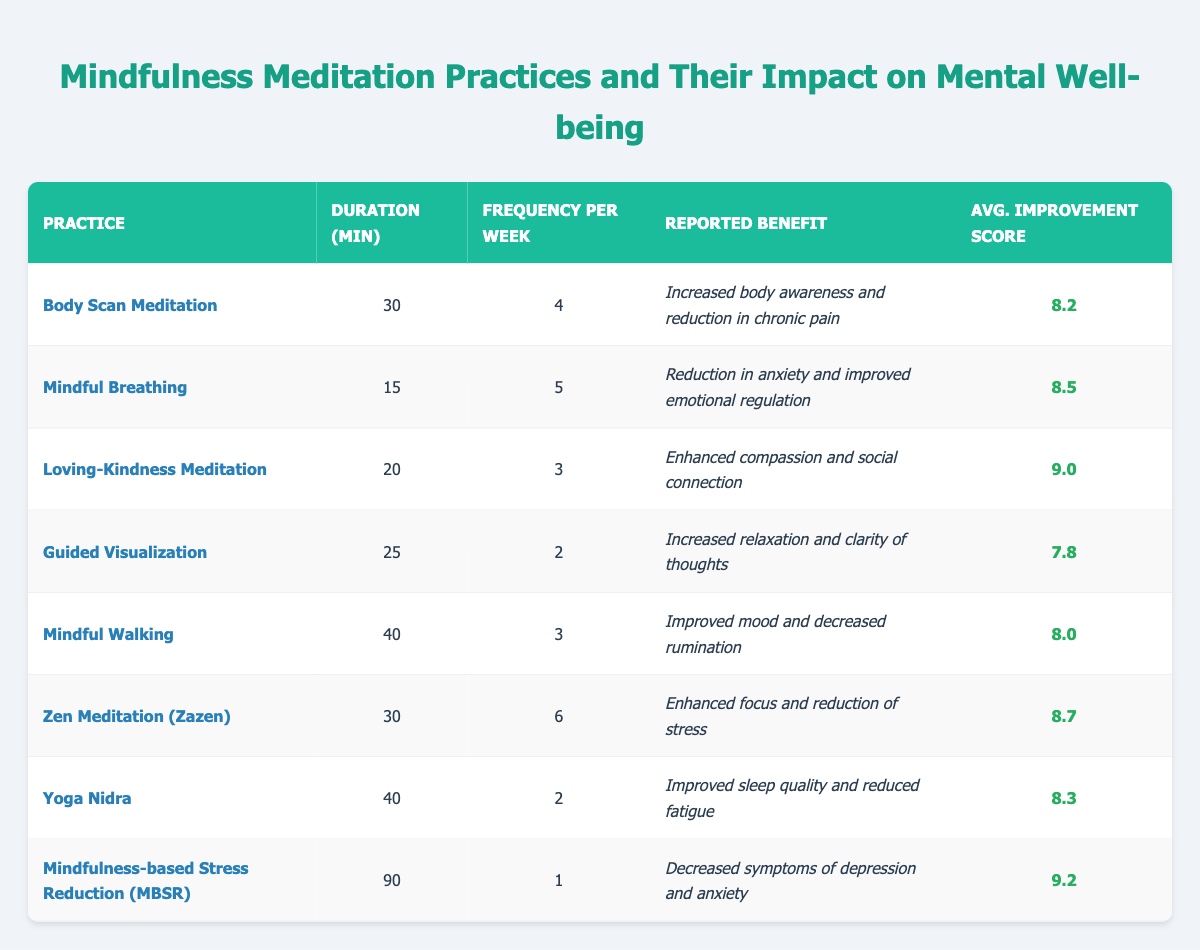What is the average improvement score for the "Mindful Breathing" meditation practice? The table shows an improvement score for each meditation practice. For "Mindful Breathing", the average improvement score is listed directly in the table as 8.5.
Answer: 8.5 How many minutes per week is spent on "Mindfulness-based Stress Reduction (MBSR)"? The table indicates that MBSR has a duration of 90 minutes once a week. Hence, spending per week would be 90 minutes.
Answer: 90 minutes Which practice has the highest average improvement score? By reviewing the average improvement scores listed in the table, the practice with the highest score is "Mindfulness-based Stress Reduction (MBSR)", which scores 9.2.
Answer: Mindfulness-based Stress Reduction (MBSR) Is the frequency of "Guided Visualization" greater than or equal to 3 times per week? The table states that "Guided Visualization" is practiced 2 times per week. Since 2 is less than 3, the answer is no.
Answer: No What practices have an average improvement score greater than 8.5? Looking at the scores in the table, the practices with scores greater than 8.5 are "Loving-Kindness Meditation" (9.0) and "Mindfulness-based Stress Reduction (MBSR)" (9.2). Both practices meet this criteria.
Answer: Loving-Kindness Meditation, Mindfulness-based Stress Reduction (MBSR) Calculate the total duration of practice for "Yoga Nidra" and "Mindful Walking" in minutes. The duration for "Yoga Nidra" is 40 minutes and for "Mindful Walking" it is 40 minutes as well. Adding them gives 40 + 40 = 80 minutes total.
Answer: 80 minutes Which mindfulness practice has the shortest duration per session? Reviewing the durations listed in the table, "Mindful Breathing" has the shortest duration at 15 minutes per session.
Answer: Mindful Breathing If someone practices "Zen Meditation (Zazen)" 6 times a week, how much total time will they spend on it in a week? "Zen Meditation (Zazen)" requires 30 minutes per session. Practicing 6 times a week means 30 minutes x 6 = 180 minutes total per week.
Answer: 180 minutes Which reported benefit is common between "Mindful Walking" and "Yoga Nidra"? The reported benefit for "Mindful Walking" is improved mood and for "Yoga Nidra" is improved sleep quality. Both practices focus on enhancing personal well-being, but they target different aspects. Therefore, the commonality lies in their intent to improve overall mental state rather than specific benefits.
Answer: Improved mood and mental state enhancement What is the frequency of "Body Scan Meditation"? The frequency for "Body Scan Meditation" is directly given in the table as being 4 times per week.
Answer: 4 times per week 